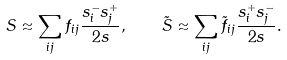<formula> <loc_0><loc_0><loc_500><loc_500>S \approx \sum _ { i j } f _ { i j } \frac { s _ { i } ^ { - } s _ { j } ^ { + } } { 2 s } , \quad \tilde { S } \approx \sum _ { i j } \tilde { f } _ { i j } \frac { s _ { i } ^ { + } s _ { j } ^ { - } } { 2 s } .</formula> 